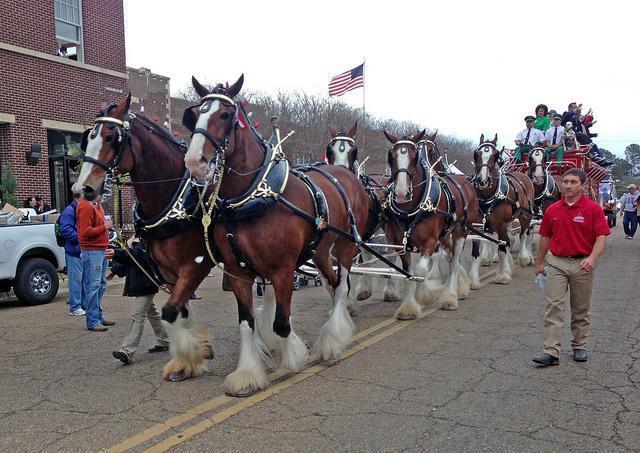How many horses are there?
Give a very brief answer. 8. How many horses are in the first row?
Give a very brief answer. 2. How many white horses do you see?
Give a very brief answer. 0. How many horses?
Give a very brief answer. 8. How many people are there?
Give a very brief answer. 2. 